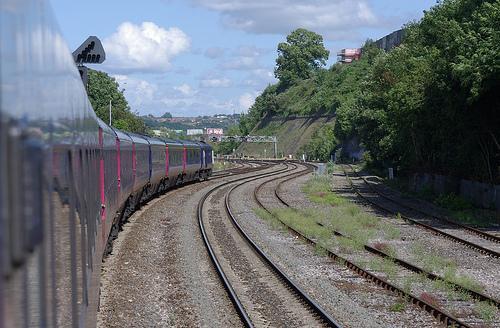How many cars does the train have?
Give a very brief answer. 8. How many train cars can be seen?
Give a very brief answer. 8. 